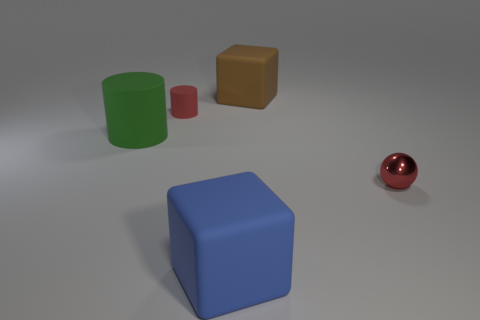Add 2 big green objects. How many objects exist? 7 Subtract all cubes. How many objects are left? 3 Add 5 blue blocks. How many blue blocks are left? 6 Add 3 small green blocks. How many small green blocks exist? 3 Subtract 0 cyan cylinders. How many objects are left? 5 Subtract all large yellow matte objects. Subtract all tiny balls. How many objects are left? 4 